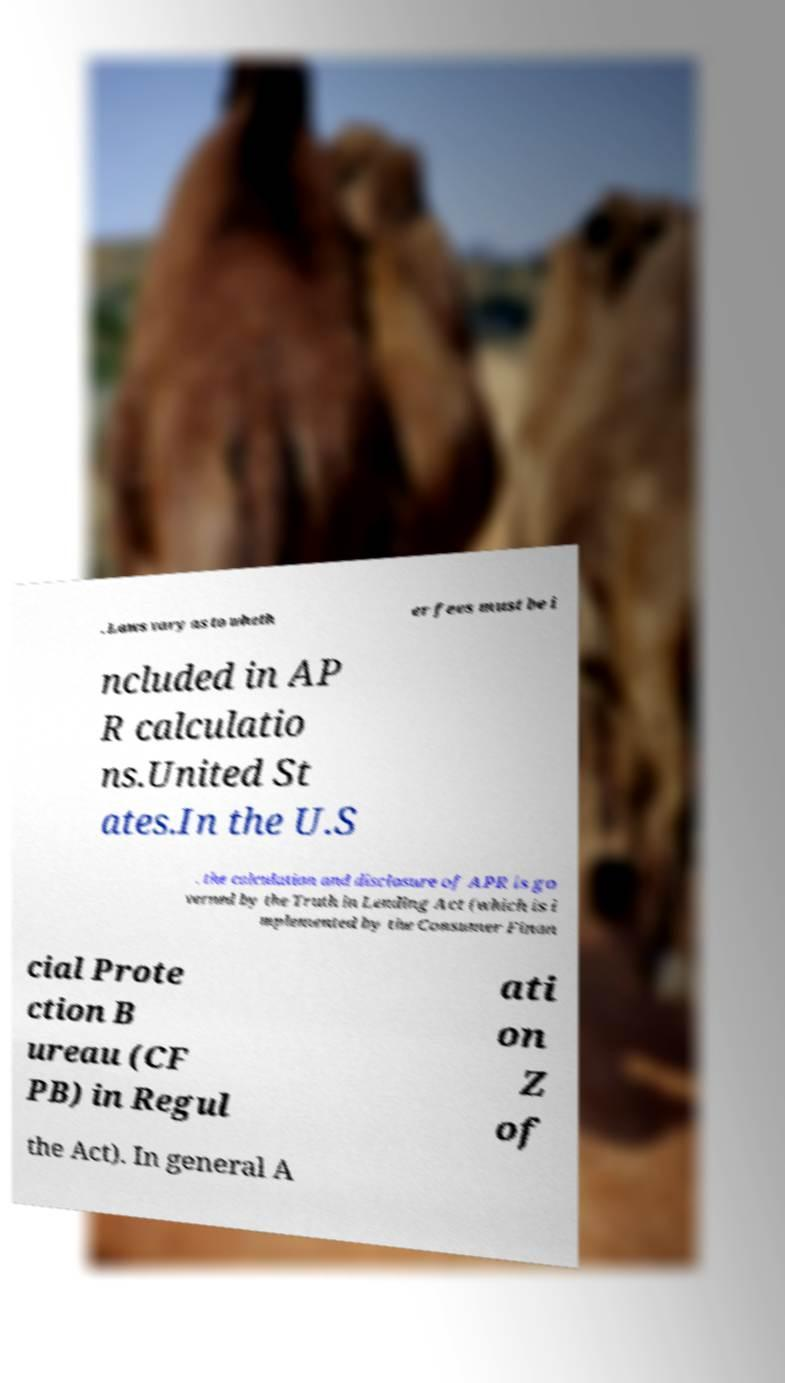Can you read and provide the text displayed in the image?This photo seems to have some interesting text. Can you extract and type it out for me? . Laws vary as to wheth er fees must be i ncluded in AP R calculatio ns.United St ates.In the U.S . the calculation and disclosure of APR is go verned by the Truth in Lending Act (which is i mplemented by the Consumer Finan cial Prote ction B ureau (CF PB) in Regul ati on Z of the Act). In general A 